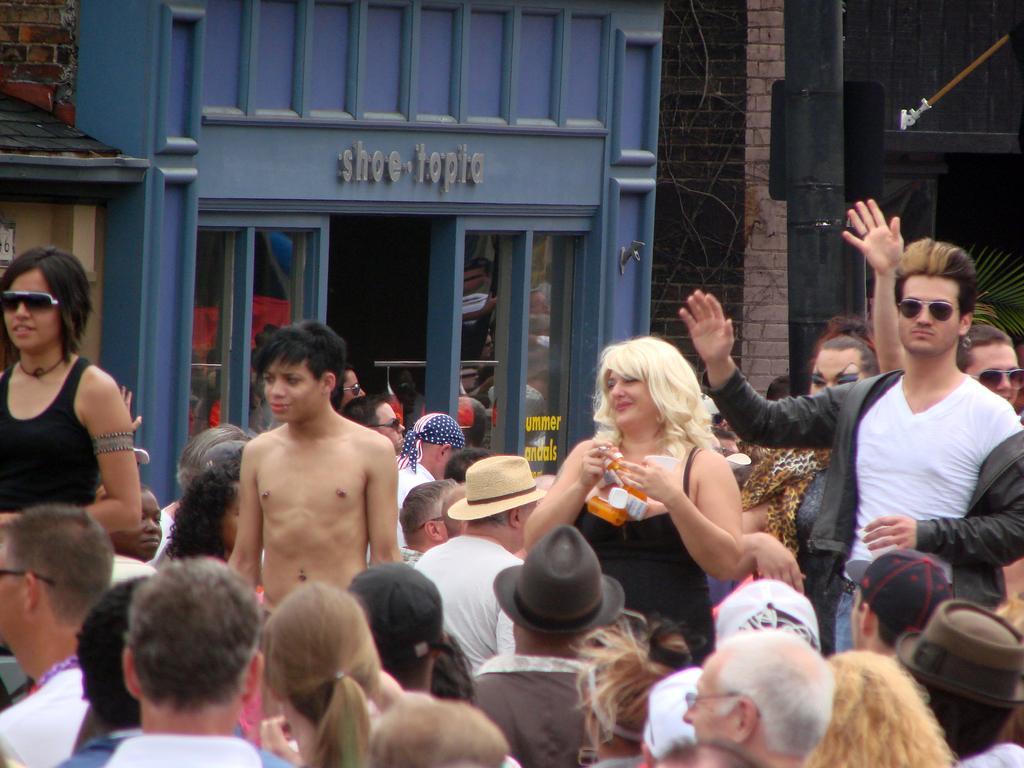Please provide a concise description of this image. At the bottom of the image few people are standing. Behind them we can see some buildings. 